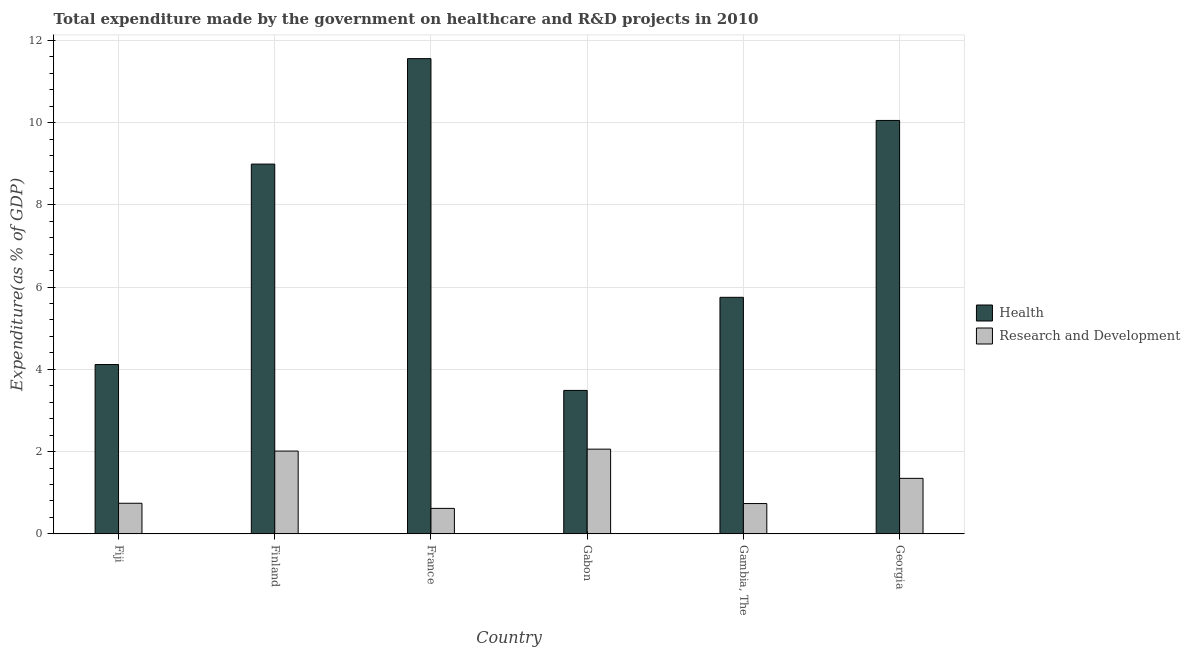How many groups of bars are there?
Keep it short and to the point. 6. What is the label of the 3rd group of bars from the left?
Your response must be concise. France. In how many cases, is the number of bars for a given country not equal to the number of legend labels?
Keep it short and to the point. 0. What is the expenditure in r&d in France?
Offer a terse response. 0.62. Across all countries, what is the maximum expenditure in healthcare?
Your answer should be compact. 11.55. Across all countries, what is the minimum expenditure in r&d?
Your answer should be very brief. 0.62. In which country was the expenditure in healthcare minimum?
Provide a succinct answer. Gabon. What is the total expenditure in healthcare in the graph?
Your answer should be very brief. 43.95. What is the difference between the expenditure in r&d in Fiji and that in Georgia?
Give a very brief answer. -0.61. What is the difference between the expenditure in healthcare in Fiji and the expenditure in r&d in Georgia?
Offer a terse response. 2.77. What is the average expenditure in healthcare per country?
Give a very brief answer. 7.33. What is the difference between the expenditure in healthcare and expenditure in r&d in Fiji?
Keep it short and to the point. 3.37. In how many countries, is the expenditure in r&d greater than 2.8 %?
Ensure brevity in your answer.  0. What is the ratio of the expenditure in healthcare in France to that in Gambia, The?
Offer a terse response. 2.01. Is the expenditure in r&d in Finland less than that in France?
Ensure brevity in your answer.  No. What is the difference between the highest and the second highest expenditure in r&d?
Ensure brevity in your answer.  0.05. What is the difference between the highest and the lowest expenditure in r&d?
Provide a short and direct response. 1.44. Is the sum of the expenditure in healthcare in France and Gambia, The greater than the maximum expenditure in r&d across all countries?
Your answer should be very brief. Yes. What does the 2nd bar from the left in Fiji represents?
Your answer should be compact. Research and Development. What does the 1st bar from the right in Fiji represents?
Offer a terse response. Research and Development. How many countries are there in the graph?
Provide a succinct answer. 6. Does the graph contain grids?
Your answer should be compact. Yes. How many legend labels are there?
Your answer should be very brief. 2. How are the legend labels stacked?
Your response must be concise. Vertical. What is the title of the graph?
Make the answer very short. Total expenditure made by the government on healthcare and R&D projects in 2010. What is the label or title of the X-axis?
Ensure brevity in your answer.  Country. What is the label or title of the Y-axis?
Ensure brevity in your answer.  Expenditure(as % of GDP). What is the Expenditure(as % of GDP) in Health in Fiji?
Give a very brief answer. 4.12. What is the Expenditure(as % of GDP) in Research and Development in Fiji?
Your response must be concise. 0.74. What is the Expenditure(as % of GDP) in Health in Finland?
Your answer should be compact. 8.99. What is the Expenditure(as % of GDP) of Research and Development in Finland?
Ensure brevity in your answer.  2.01. What is the Expenditure(as % of GDP) in Health in France?
Provide a short and direct response. 11.55. What is the Expenditure(as % of GDP) of Research and Development in France?
Provide a short and direct response. 0.62. What is the Expenditure(as % of GDP) in Health in Gabon?
Give a very brief answer. 3.49. What is the Expenditure(as % of GDP) in Research and Development in Gabon?
Give a very brief answer. 2.06. What is the Expenditure(as % of GDP) of Health in Gambia, The?
Offer a terse response. 5.75. What is the Expenditure(as % of GDP) in Research and Development in Gambia, The?
Your answer should be compact. 0.74. What is the Expenditure(as % of GDP) in Health in Georgia?
Keep it short and to the point. 10.05. What is the Expenditure(as % of GDP) of Research and Development in Georgia?
Your answer should be compact. 1.35. Across all countries, what is the maximum Expenditure(as % of GDP) of Health?
Your answer should be compact. 11.55. Across all countries, what is the maximum Expenditure(as % of GDP) in Research and Development?
Your answer should be very brief. 2.06. Across all countries, what is the minimum Expenditure(as % of GDP) of Health?
Your answer should be compact. 3.49. Across all countries, what is the minimum Expenditure(as % of GDP) of Research and Development?
Offer a very short reply. 0.62. What is the total Expenditure(as % of GDP) in Health in the graph?
Provide a succinct answer. 43.95. What is the total Expenditure(as % of GDP) of Research and Development in the graph?
Your response must be concise. 7.52. What is the difference between the Expenditure(as % of GDP) in Health in Fiji and that in Finland?
Your response must be concise. -4.87. What is the difference between the Expenditure(as % of GDP) in Research and Development in Fiji and that in Finland?
Your answer should be compact. -1.27. What is the difference between the Expenditure(as % of GDP) of Health in Fiji and that in France?
Make the answer very short. -7.44. What is the difference between the Expenditure(as % of GDP) of Research and Development in Fiji and that in France?
Make the answer very short. 0.12. What is the difference between the Expenditure(as % of GDP) of Health in Fiji and that in Gabon?
Offer a very short reply. 0.63. What is the difference between the Expenditure(as % of GDP) of Research and Development in Fiji and that in Gabon?
Your response must be concise. -1.32. What is the difference between the Expenditure(as % of GDP) of Health in Fiji and that in Gambia, The?
Offer a terse response. -1.63. What is the difference between the Expenditure(as % of GDP) of Research and Development in Fiji and that in Gambia, The?
Keep it short and to the point. 0.01. What is the difference between the Expenditure(as % of GDP) in Health in Fiji and that in Georgia?
Provide a succinct answer. -5.93. What is the difference between the Expenditure(as % of GDP) in Research and Development in Fiji and that in Georgia?
Your answer should be very brief. -0.61. What is the difference between the Expenditure(as % of GDP) of Health in Finland and that in France?
Your answer should be compact. -2.56. What is the difference between the Expenditure(as % of GDP) in Research and Development in Finland and that in France?
Offer a very short reply. 1.39. What is the difference between the Expenditure(as % of GDP) in Health in Finland and that in Gabon?
Keep it short and to the point. 5.5. What is the difference between the Expenditure(as % of GDP) in Research and Development in Finland and that in Gabon?
Give a very brief answer. -0.05. What is the difference between the Expenditure(as % of GDP) in Health in Finland and that in Gambia, The?
Offer a very short reply. 3.24. What is the difference between the Expenditure(as % of GDP) of Research and Development in Finland and that in Gambia, The?
Ensure brevity in your answer.  1.28. What is the difference between the Expenditure(as % of GDP) of Health in Finland and that in Georgia?
Provide a short and direct response. -1.06. What is the difference between the Expenditure(as % of GDP) in Research and Development in Finland and that in Georgia?
Give a very brief answer. 0.66. What is the difference between the Expenditure(as % of GDP) of Health in France and that in Gabon?
Keep it short and to the point. 8.07. What is the difference between the Expenditure(as % of GDP) in Research and Development in France and that in Gabon?
Provide a short and direct response. -1.44. What is the difference between the Expenditure(as % of GDP) of Health in France and that in Gambia, The?
Provide a succinct answer. 5.8. What is the difference between the Expenditure(as % of GDP) in Research and Development in France and that in Gambia, The?
Your answer should be very brief. -0.12. What is the difference between the Expenditure(as % of GDP) in Health in France and that in Georgia?
Your response must be concise. 1.5. What is the difference between the Expenditure(as % of GDP) in Research and Development in France and that in Georgia?
Your answer should be compact. -0.73. What is the difference between the Expenditure(as % of GDP) of Health in Gabon and that in Gambia, The?
Your response must be concise. -2.26. What is the difference between the Expenditure(as % of GDP) of Research and Development in Gabon and that in Gambia, The?
Make the answer very short. 1.32. What is the difference between the Expenditure(as % of GDP) in Health in Gabon and that in Georgia?
Offer a very short reply. -6.56. What is the difference between the Expenditure(as % of GDP) of Research and Development in Gabon and that in Georgia?
Your response must be concise. 0.71. What is the difference between the Expenditure(as % of GDP) in Health in Gambia, The and that in Georgia?
Provide a short and direct response. -4.3. What is the difference between the Expenditure(as % of GDP) in Research and Development in Gambia, The and that in Georgia?
Offer a terse response. -0.61. What is the difference between the Expenditure(as % of GDP) of Health in Fiji and the Expenditure(as % of GDP) of Research and Development in Finland?
Ensure brevity in your answer.  2.1. What is the difference between the Expenditure(as % of GDP) of Health in Fiji and the Expenditure(as % of GDP) of Research and Development in France?
Your answer should be compact. 3.5. What is the difference between the Expenditure(as % of GDP) of Health in Fiji and the Expenditure(as % of GDP) of Research and Development in Gabon?
Your answer should be compact. 2.06. What is the difference between the Expenditure(as % of GDP) of Health in Fiji and the Expenditure(as % of GDP) of Research and Development in Gambia, The?
Provide a succinct answer. 3.38. What is the difference between the Expenditure(as % of GDP) of Health in Fiji and the Expenditure(as % of GDP) of Research and Development in Georgia?
Offer a terse response. 2.77. What is the difference between the Expenditure(as % of GDP) of Health in Finland and the Expenditure(as % of GDP) of Research and Development in France?
Offer a very short reply. 8.37. What is the difference between the Expenditure(as % of GDP) in Health in Finland and the Expenditure(as % of GDP) in Research and Development in Gabon?
Provide a short and direct response. 6.93. What is the difference between the Expenditure(as % of GDP) in Health in Finland and the Expenditure(as % of GDP) in Research and Development in Gambia, The?
Offer a very short reply. 8.25. What is the difference between the Expenditure(as % of GDP) of Health in Finland and the Expenditure(as % of GDP) of Research and Development in Georgia?
Offer a very short reply. 7.64. What is the difference between the Expenditure(as % of GDP) in Health in France and the Expenditure(as % of GDP) in Research and Development in Gabon?
Give a very brief answer. 9.49. What is the difference between the Expenditure(as % of GDP) in Health in France and the Expenditure(as % of GDP) in Research and Development in Gambia, The?
Your response must be concise. 10.82. What is the difference between the Expenditure(as % of GDP) in Health in France and the Expenditure(as % of GDP) in Research and Development in Georgia?
Provide a succinct answer. 10.2. What is the difference between the Expenditure(as % of GDP) in Health in Gabon and the Expenditure(as % of GDP) in Research and Development in Gambia, The?
Give a very brief answer. 2.75. What is the difference between the Expenditure(as % of GDP) in Health in Gabon and the Expenditure(as % of GDP) in Research and Development in Georgia?
Offer a terse response. 2.14. What is the difference between the Expenditure(as % of GDP) in Health in Gambia, The and the Expenditure(as % of GDP) in Research and Development in Georgia?
Ensure brevity in your answer.  4.4. What is the average Expenditure(as % of GDP) in Health per country?
Ensure brevity in your answer.  7.33. What is the average Expenditure(as % of GDP) in Research and Development per country?
Give a very brief answer. 1.25. What is the difference between the Expenditure(as % of GDP) in Health and Expenditure(as % of GDP) in Research and Development in Fiji?
Ensure brevity in your answer.  3.37. What is the difference between the Expenditure(as % of GDP) in Health and Expenditure(as % of GDP) in Research and Development in Finland?
Keep it short and to the point. 6.98. What is the difference between the Expenditure(as % of GDP) in Health and Expenditure(as % of GDP) in Research and Development in France?
Ensure brevity in your answer.  10.93. What is the difference between the Expenditure(as % of GDP) in Health and Expenditure(as % of GDP) in Research and Development in Gabon?
Your response must be concise. 1.43. What is the difference between the Expenditure(as % of GDP) of Health and Expenditure(as % of GDP) of Research and Development in Gambia, The?
Provide a short and direct response. 5.01. What is the difference between the Expenditure(as % of GDP) in Health and Expenditure(as % of GDP) in Research and Development in Georgia?
Your response must be concise. 8.7. What is the ratio of the Expenditure(as % of GDP) of Health in Fiji to that in Finland?
Give a very brief answer. 0.46. What is the ratio of the Expenditure(as % of GDP) in Research and Development in Fiji to that in Finland?
Your answer should be compact. 0.37. What is the ratio of the Expenditure(as % of GDP) in Health in Fiji to that in France?
Ensure brevity in your answer.  0.36. What is the ratio of the Expenditure(as % of GDP) of Research and Development in Fiji to that in France?
Your answer should be very brief. 1.2. What is the ratio of the Expenditure(as % of GDP) in Health in Fiji to that in Gabon?
Provide a succinct answer. 1.18. What is the ratio of the Expenditure(as % of GDP) of Research and Development in Fiji to that in Gabon?
Provide a succinct answer. 0.36. What is the ratio of the Expenditure(as % of GDP) in Health in Fiji to that in Gambia, The?
Your answer should be compact. 0.72. What is the ratio of the Expenditure(as % of GDP) of Research and Development in Fiji to that in Gambia, The?
Make the answer very short. 1.01. What is the ratio of the Expenditure(as % of GDP) in Health in Fiji to that in Georgia?
Offer a terse response. 0.41. What is the ratio of the Expenditure(as % of GDP) of Research and Development in Fiji to that in Georgia?
Offer a very short reply. 0.55. What is the ratio of the Expenditure(as % of GDP) in Health in Finland to that in France?
Keep it short and to the point. 0.78. What is the ratio of the Expenditure(as % of GDP) in Research and Development in Finland to that in France?
Keep it short and to the point. 3.25. What is the ratio of the Expenditure(as % of GDP) of Health in Finland to that in Gabon?
Offer a very short reply. 2.58. What is the ratio of the Expenditure(as % of GDP) of Research and Development in Finland to that in Gabon?
Provide a short and direct response. 0.98. What is the ratio of the Expenditure(as % of GDP) in Health in Finland to that in Gambia, The?
Provide a short and direct response. 1.56. What is the ratio of the Expenditure(as % of GDP) in Research and Development in Finland to that in Gambia, The?
Give a very brief answer. 2.73. What is the ratio of the Expenditure(as % of GDP) in Health in Finland to that in Georgia?
Your answer should be very brief. 0.89. What is the ratio of the Expenditure(as % of GDP) in Research and Development in Finland to that in Georgia?
Keep it short and to the point. 1.49. What is the ratio of the Expenditure(as % of GDP) of Health in France to that in Gabon?
Offer a very short reply. 3.31. What is the ratio of the Expenditure(as % of GDP) in Research and Development in France to that in Gabon?
Make the answer very short. 0.3. What is the ratio of the Expenditure(as % of GDP) in Health in France to that in Gambia, The?
Provide a short and direct response. 2.01. What is the ratio of the Expenditure(as % of GDP) of Research and Development in France to that in Gambia, The?
Your answer should be very brief. 0.84. What is the ratio of the Expenditure(as % of GDP) in Health in France to that in Georgia?
Your response must be concise. 1.15. What is the ratio of the Expenditure(as % of GDP) in Research and Development in France to that in Georgia?
Your response must be concise. 0.46. What is the ratio of the Expenditure(as % of GDP) of Health in Gabon to that in Gambia, The?
Provide a short and direct response. 0.61. What is the ratio of the Expenditure(as % of GDP) in Research and Development in Gabon to that in Gambia, The?
Give a very brief answer. 2.79. What is the ratio of the Expenditure(as % of GDP) of Health in Gabon to that in Georgia?
Your answer should be compact. 0.35. What is the ratio of the Expenditure(as % of GDP) in Research and Development in Gabon to that in Georgia?
Your answer should be very brief. 1.53. What is the ratio of the Expenditure(as % of GDP) of Health in Gambia, The to that in Georgia?
Provide a succinct answer. 0.57. What is the ratio of the Expenditure(as % of GDP) in Research and Development in Gambia, The to that in Georgia?
Give a very brief answer. 0.55. What is the difference between the highest and the second highest Expenditure(as % of GDP) of Health?
Provide a short and direct response. 1.5. What is the difference between the highest and the second highest Expenditure(as % of GDP) in Research and Development?
Your response must be concise. 0.05. What is the difference between the highest and the lowest Expenditure(as % of GDP) of Health?
Your response must be concise. 8.07. What is the difference between the highest and the lowest Expenditure(as % of GDP) in Research and Development?
Your answer should be very brief. 1.44. 